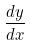Convert formula to latex. <formula><loc_0><loc_0><loc_500><loc_500>\frac { d y } { d x }</formula> 